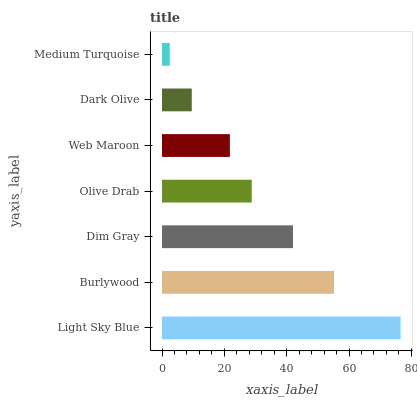Is Medium Turquoise the minimum?
Answer yes or no. Yes. Is Light Sky Blue the maximum?
Answer yes or no. Yes. Is Burlywood the minimum?
Answer yes or no. No. Is Burlywood the maximum?
Answer yes or no. No. Is Light Sky Blue greater than Burlywood?
Answer yes or no. Yes. Is Burlywood less than Light Sky Blue?
Answer yes or no. Yes. Is Burlywood greater than Light Sky Blue?
Answer yes or no. No. Is Light Sky Blue less than Burlywood?
Answer yes or no. No. Is Olive Drab the high median?
Answer yes or no. Yes. Is Olive Drab the low median?
Answer yes or no. Yes. Is Burlywood the high median?
Answer yes or no. No. Is Web Maroon the low median?
Answer yes or no. No. 